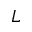<formula> <loc_0><loc_0><loc_500><loc_500>L</formula> 